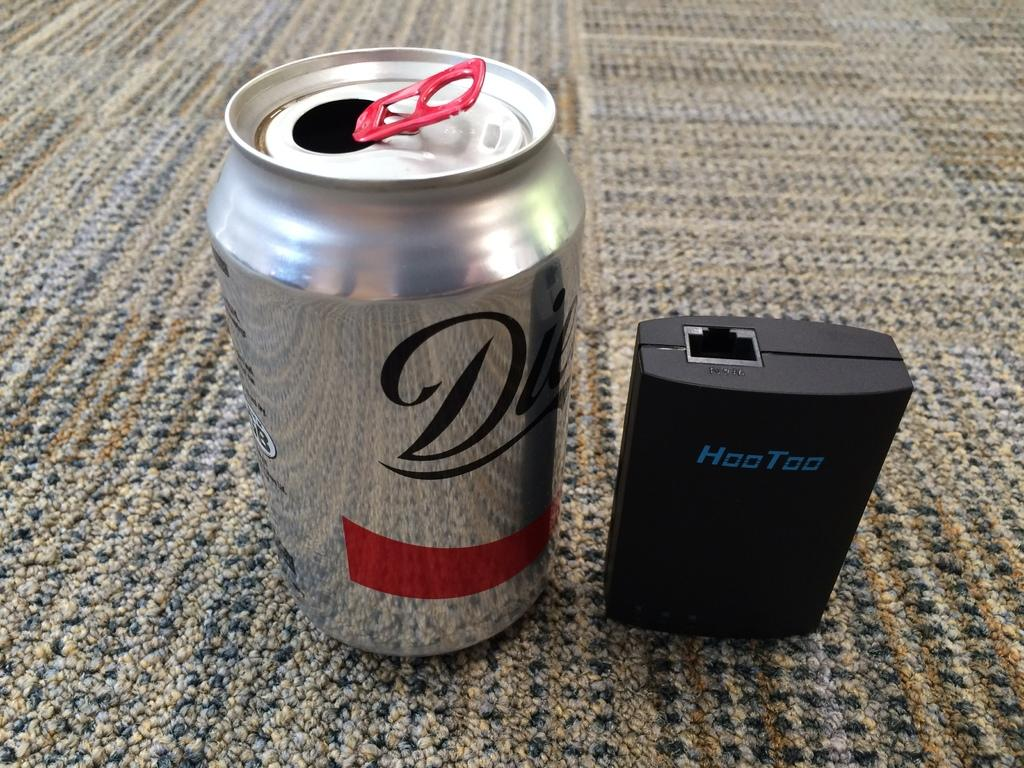<image>
Give a short and clear explanation of the subsequent image. A can of Diet Coke sits on the floor next to a USB port. 